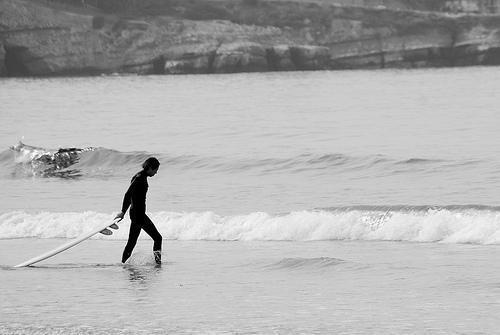How many people on the beach?
Give a very brief answer. 1. How many waves rolling in?
Give a very brief answer. 2. 